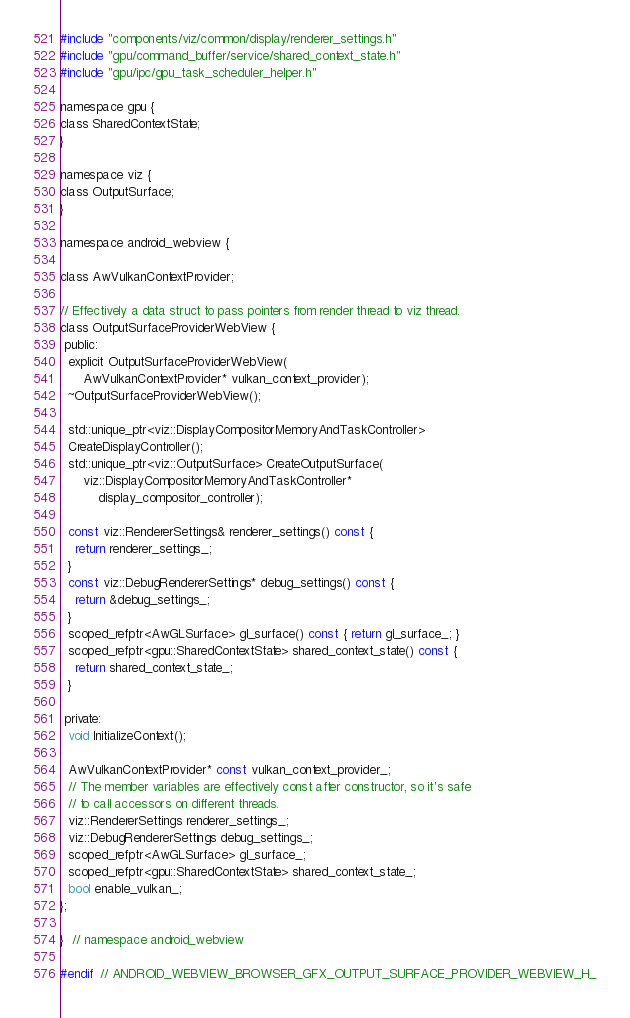<code> <loc_0><loc_0><loc_500><loc_500><_C_>#include "components/viz/common/display/renderer_settings.h"
#include "gpu/command_buffer/service/shared_context_state.h"
#include "gpu/ipc/gpu_task_scheduler_helper.h"

namespace gpu {
class SharedContextState;
}

namespace viz {
class OutputSurface;
}

namespace android_webview {

class AwVulkanContextProvider;

// Effectively a data struct to pass pointers from render thread to viz thread.
class OutputSurfaceProviderWebView {
 public:
  explicit OutputSurfaceProviderWebView(
      AwVulkanContextProvider* vulkan_context_provider);
  ~OutputSurfaceProviderWebView();

  std::unique_ptr<viz::DisplayCompositorMemoryAndTaskController>
  CreateDisplayController();
  std::unique_ptr<viz::OutputSurface> CreateOutputSurface(
      viz::DisplayCompositorMemoryAndTaskController*
          display_compositor_controller);

  const viz::RendererSettings& renderer_settings() const {
    return renderer_settings_;
  }
  const viz::DebugRendererSettings* debug_settings() const {
    return &debug_settings_;
  }
  scoped_refptr<AwGLSurface> gl_surface() const { return gl_surface_; }
  scoped_refptr<gpu::SharedContextState> shared_context_state() const {
    return shared_context_state_;
  }

 private:
  void InitializeContext();

  AwVulkanContextProvider* const vulkan_context_provider_;
  // The member variables are effectively const after constructor, so it's safe
  // to call accessors on different threads.
  viz::RendererSettings renderer_settings_;
  viz::DebugRendererSettings debug_settings_;
  scoped_refptr<AwGLSurface> gl_surface_;
  scoped_refptr<gpu::SharedContextState> shared_context_state_;
  bool enable_vulkan_;
};

}  // namespace android_webview

#endif  // ANDROID_WEBVIEW_BROWSER_GFX_OUTPUT_SURFACE_PROVIDER_WEBVIEW_H_
</code> 